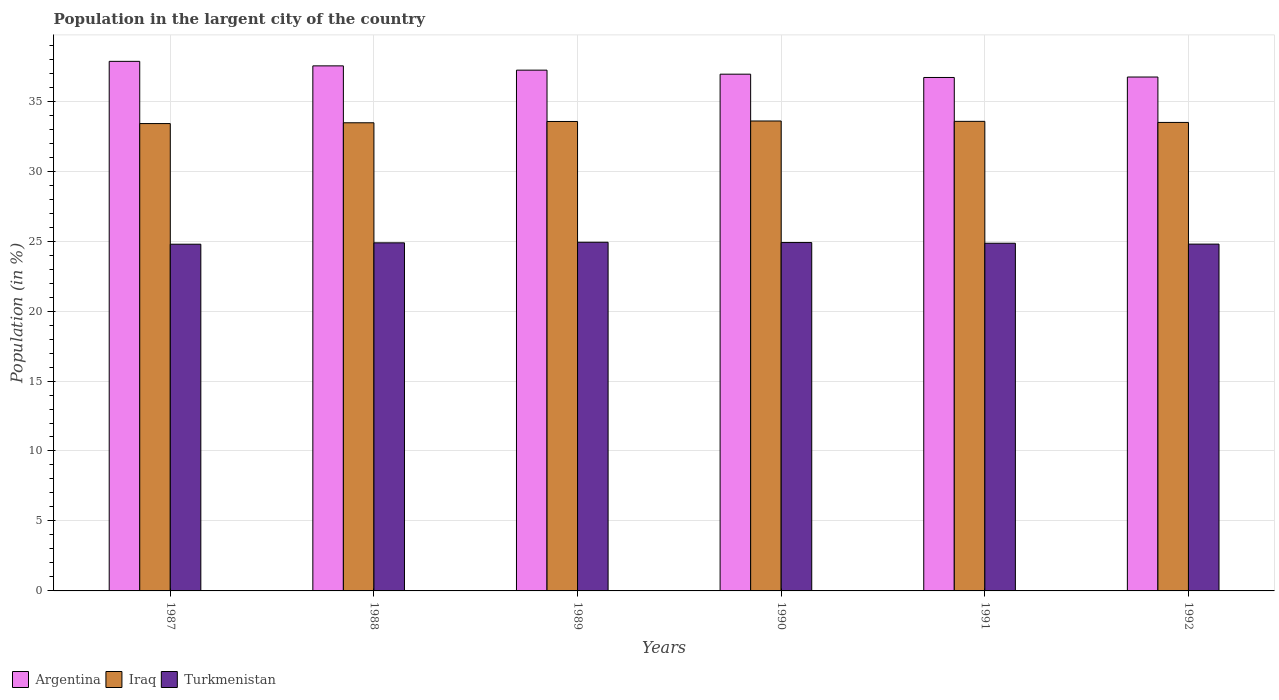Are the number of bars on each tick of the X-axis equal?
Ensure brevity in your answer.  Yes. How many bars are there on the 6th tick from the left?
Your answer should be very brief. 3. How many bars are there on the 2nd tick from the right?
Make the answer very short. 3. What is the label of the 6th group of bars from the left?
Keep it short and to the point. 1992. In how many cases, is the number of bars for a given year not equal to the number of legend labels?
Provide a short and direct response. 0. What is the percentage of population in the largent city in Turkmenistan in 1987?
Offer a terse response. 24.78. Across all years, what is the maximum percentage of population in the largent city in Turkmenistan?
Your response must be concise. 24.92. Across all years, what is the minimum percentage of population in the largent city in Turkmenistan?
Offer a terse response. 24.78. What is the total percentage of population in the largent city in Turkmenistan in the graph?
Ensure brevity in your answer.  149.1. What is the difference between the percentage of population in the largent city in Argentina in 1987 and that in 1991?
Ensure brevity in your answer.  1.15. What is the difference between the percentage of population in the largent city in Iraq in 1987 and the percentage of population in the largent city in Turkmenistan in 1991?
Provide a short and direct response. 8.55. What is the average percentage of population in the largent city in Turkmenistan per year?
Give a very brief answer. 24.85. In the year 1991, what is the difference between the percentage of population in the largent city in Argentina and percentage of population in the largent city in Turkmenistan?
Keep it short and to the point. 11.85. In how many years, is the percentage of population in the largent city in Argentina greater than 3 %?
Provide a succinct answer. 6. What is the ratio of the percentage of population in the largent city in Turkmenistan in 1991 to that in 1992?
Give a very brief answer. 1. Is the percentage of population in the largent city in Iraq in 1987 less than that in 1990?
Keep it short and to the point. Yes. What is the difference between the highest and the second highest percentage of population in the largent city in Argentina?
Your response must be concise. 0.32. What is the difference between the highest and the lowest percentage of population in the largent city in Argentina?
Your response must be concise. 1.15. What does the 1st bar from the left in 1990 represents?
Give a very brief answer. Argentina. What does the 2nd bar from the right in 1989 represents?
Offer a terse response. Iraq. How many bars are there?
Keep it short and to the point. 18. Are all the bars in the graph horizontal?
Keep it short and to the point. No. Does the graph contain grids?
Your answer should be compact. Yes. What is the title of the graph?
Make the answer very short. Population in the largent city of the country. What is the label or title of the X-axis?
Make the answer very short. Years. What is the label or title of the Y-axis?
Offer a very short reply. Population (in %). What is the Population (in %) in Argentina in 1987?
Your response must be concise. 37.85. What is the Population (in %) of Iraq in 1987?
Keep it short and to the point. 33.4. What is the Population (in %) of Turkmenistan in 1987?
Your response must be concise. 24.78. What is the Population (in %) of Argentina in 1988?
Ensure brevity in your answer.  37.52. What is the Population (in %) in Iraq in 1988?
Your answer should be very brief. 33.46. What is the Population (in %) of Turkmenistan in 1988?
Offer a very short reply. 24.88. What is the Population (in %) of Argentina in 1989?
Give a very brief answer. 37.22. What is the Population (in %) in Iraq in 1989?
Make the answer very short. 33.55. What is the Population (in %) of Turkmenistan in 1989?
Give a very brief answer. 24.92. What is the Population (in %) in Argentina in 1990?
Offer a very short reply. 36.93. What is the Population (in %) of Iraq in 1990?
Keep it short and to the point. 33.58. What is the Population (in %) in Turkmenistan in 1990?
Offer a terse response. 24.9. What is the Population (in %) of Argentina in 1991?
Offer a terse response. 36.69. What is the Population (in %) of Iraq in 1991?
Provide a succinct answer. 33.56. What is the Population (in %) of Turkmenistan in 1991?
Your answer should be compact. 24.85. What is the Population (in %) of Argentina in 1992?
Ensure brevity in your answer.  36.73. What is the Population (in %) of Iraq in 1992?
Your answer should be compact. 33.48. What is the Population (in %) in Turkmenistan in 1992?
Provide a succinct answer. 24.78. Across all years, what is the maximum Population (in %) in Argentina?
Make the answer very short. 37.85. Across all years, what is the maximum Population (in %) in Iraq?
Your response must be concise. 33.58. Across all years, what is the maximum Population (in %) of Turkmenistan?
Offer a very short reply. 24.92. Across all years, what is the minimum Population (in %) of Argentina?
Make the answer very short. 36.69. Across all years, what is the minimum Population (in %) in Iraq?
Provide a short and direct response. 33.4. Across all years, what is the minimum Population (in %) of Turkmenistan?
Your answer should be very brief. 24.78. What is the total Population (in %) of Argentina in the graph?
Keep it short and to the point. 222.93. What is the total Population (in %) in Iraq in the graph?
Make the answer very short. 201.02. What is the total Population (in %) in Turkmenistan in the graph?
Your answer should be compact. 149.1. What is the difference between the Population (in %) of Argentina in 1987 and that in 1988?
Keep it short and to the point. 0.32. What is the difference between the Population (in %) of Iraq in 1987 and that in 1988?
Provide a succinct answer. -0.06. What is the difference between the Population (in %) in Turkmenistan in 1987 and that in 1988?
Offer a very short reply. -0.1. What is the difference between the Population (in %) of Argentina in 1987 and that in 1989?
Offer a very short reply. 0.63. What is the difference between the Population (in %) of Iraq in 1987 and that in 1989?
Your answer should be compact. -0.15. What is the difference between the Population (in %) of Turkmenistan in 1987 and that in 1989?
Your answer should be compact. -0.14. What is the difference between the Population (in %) of Argentina in 1987 and that in 1990?
Provide a succinct answer. 0.92. What is the difference between the Population (in %) of Iraq in 1987 and that in 1990?
Keep it short and to the point. -0.18. What is the difference between the Population (in %) in Turkmenistan in 1987 and that in 1990?
Make the answer very short. -0.12. What is the difference between the Population (in %) in Argentina in 1987 and that in 1991?
Your response must be concise. 1.15. What is the difference between the Population (in %) of Iraq in 1987 and that in 1991?
Make the answer very short. -0.16. What is the difference between the Population (in %) of Turkmenistan in 1987 and that in 1991?
Make the answer very short. -0.07. What is the difference between the Population (in %) in Argentina in 1987 and that in 1992?
Offer a very short reply. 1.12. What is the difference between the Population (in %) of Iraq in 1987 and that in 1992?
Your answer should be very brief. -0.08. What is the difference between the Population (in %) of Turkmenistan in 1987 and that in 1992?
Give a very brief answer. -0.01. What is the difference between the Population (in %) in Argentina in 1988 and that in 1989?
Offer a terse response. 0.31. What is the difference between the Population (in %) in Iraq in 1988 and that in 1989?
Your response must be concise. -0.09. What is the difference between the Population (in %) in Turkmenistan in 1988 and that in 1989?
Your answer should be very brief. -0.04. What is the difference between the Population (in %) in Argentina in 1988 and that in 1990?
Offer a terse response. 0.59. What is the difference between the Population (in %) of Iraq in 1988 and that in 1990?
Provide a succinct answer. -0.13. What is the difference between the Population (in %) in Turkmenistan in 1988 and that in 1990?
Your answer should be compact. -0.02. What is the difference between the Population (in %) of Argentina in 1988 and that in 1991?
Ensure brevity in your answer.  0.83. What is the difference between the Population (in %) of Iraq in 1988 and that in 1991?
Provide a short and direct response. -0.1. What is the difference between the Population (in %) of Turkmenistan in 1988 and that in 1991?
Ensure brevity in your answer.  0.03. What is the difference between the Population (in %) of Argentina in 1988 and that in 1992?
Keep it short and to the point. 0.8. What is the difference between the Population (in %) of Iraq in 1988 and that in 1992?
Provide a succinct answer. -0.03. What is the difference between the Population (in %) in Turkmenistan in 1988 and that in 1992?
Your answer should be compact. 0.09. What is the difference between the Population (in %) of Argentina in 1989 and that in 1990?
Your response must be concise. 0.29. What is the difference between the Population (in %) of Iraq in 1989 and that in 1990?
Ensure brevity in your answer.  -0.04. What is the difference between the Population (in %) in Turkmenistan in 1989 and that in 1990?
Offer a very short reply. 0.02. What is the difference between the Population (in %) in Argentina in 1989 and that in 1991?
Offer a very short reply. 0.52. What is the difference between the Population (in %) in Iraq in 1989 and that in 1991?
Your response must be concise. -0.01. What is the difference between the Population (in %) of Turkmenistan in 1989 and that in 1991?
Provide a short and direct response. 0.07. What is the difference between the Population (in %) of Argentina in 1989 and that in 1992?
Offer a very short reply. 0.49. What is the difference between the Population (in %) in Iraq in 1989 and that in 1992?
Give a very brief answer. 0.07. What is the difference between the Population (in %) in Turkmenistan in 1989 and that in 1992?
Make the answer very short. 0.13. What is the difference between the Population (in %) of Argentina in 1990 and that in 1991?
Your response must be concise. 0.24. What is the difference between the Population (in %) of Iraq in 1990 and that in 1991?
Offer a terse response. 0.03. What is the difference between the Population (in %) in Turkmenistan in 1990 and that in 1991?
Your answer should be compact. 0.05. What is the difference between the Population (in %) in Argentina in 1990 and that in 1992?
Give a very brief answer. 0.2. What is the difference between the Population (in %) of Iraq in 1990 and that in 1992?
Offer a very short reply. 0.1. What is the difference between the Population (in %) of Turkmenistan in 1990 and that in 1992?
Provide a short and direct response. 0.11. What is the difference between the Population (in %) in Argentina in 1991 and that in 1992?
Make the answer very short. -0.03. What is the difference between the Population (in %) in Iraq in 1991 and that in 1992?
Make the answer very short. 0.08. What is the difference between the Population (in %) of Turkmenistan in 1991 and that in 1992?
Ensure brevity in your answer.  0.06. What is the difference between the Population (in %) of Argentina in 1987 and the Population (in %) of Iraq in 1988?
Your answer should be compact. 4.39. What is the difference between the Population (in %) of Argentina in 1987 and the Population (in %) of Turkmenistan in 1988?
Give a very brief answer. 12.97. What is the difference between the Population (in %) in Iraq in 1987 and the Population (in %) in Turkmenistan in 1988?
Your answer should be compact. 8.52. What is the difference between the Population (in %) of Argentina in 1987 and the Population (in %) of Iraq in 1989?
Give a very brief answer. 4.3. What is the difference between the Population (in %) of Argentina in 1987 and the Population (in %) of Turkmenistan in 1989?
Offer a terse response. 12.93. What is the difference between the Population (in %) of Iraq in 1987 and the Population (in %) of Turkmenistan in 1989?
Your response must be concise. 8.48. What is the difference between the Population (in %) of Argentina in 1987 and the Population (in %) of Iraq in 1990?
Provide a succinct answer. 4.26. What is the difference between the Population (in %) of Argentina in 1987 and the Population (in %) of Turkmenistan in 1990?
Give a very brief answer. 12.95. What is the difference between the Population (in %) in Iraq in 1987 and the Population (in %) in Turkmenistan in 1990?
Your answer should be very brief. 8.5. What is the difference between the Population (in %) of Argentina in 1987 and the Population (in %) of Iraq in 1991?
Provide a succinct answer. 4.29. What is the difference between the Population (in %) in Argentina in 1987 and the Population (in %) in Turkmenistan in 1991?
Your response must be concise. 13. What is the difference between the Population (in %) of Iraq in 1987 and the Population (in %) of Turkmenistan in 1991?
Make the answer very short. 8.55. What is the difference between the Population (in %) of Argentina in 1987 and the Population (in %) of Iraq in 1992?
Give a very brief answer. 4.36. What is the difference between the Population (in %) of Argentina in 1987 and the Population (in %) of Turkmenistan in 1992?
Your response must be concise. 13.06. What is the difference between the Population (in %) of Iraq in 1987 and the Population (in %) of Turkmenistan in 1992?
Your answer should be compact. 8.61. What is the difference between the Population (in %) of Argentina in 1988 and the Population (in %) of Iraq in 1989?
Ensure brevity in your answer.  3.97. What is the difference between the Population (in %) in Argentina in 1988 and the Population (in %) in Turkmenistan in 1989?
Provide a short and direct response. 12.61. What is the difference between the Population (in %) of Iraq in 1988 and the Population (in %) of Turkmenistan in 1989?
Your response must be concise. 8.54. What is the difference between the Population (in %) in Argentina in 1988 and the Population (in %) in Iraq in 1990?
Offer a terse response. 3.94. What is the difference between the Population (in %) in Argentina in 1988 and the Population (in %) in Turkmenistan in 1990?
Offer a terse response. 12.63. What is the difference between the Population (in %) of Iraq in 1988 and the Population (in %) of Turkmenistan in 1990?
Offer a terse response. 8.56. What is the difference between the Population (in %) of Argentina in 1988 and the Population (in %) of Iraq in 1991?
Offer a terse response. 3.97. What is the difference between the Population (in %) of Argentina in 1988 and the Population (in %) of Turkmenistan in 1991?
Offer a terse response. 12.68. What is the difference between the Population (in %) of Iraq in 1988 and the Population (in %) of Turkmenistan in 1991?
Provide a short and direct response. 8.61. What is the difference between the Population (in %) in Argentina in 1988 and the Population (in %) in Iraq in 1992?
Offer a very short reply. 4.04. What is the difference between the Population (in %) in Argentina in 1988 and the Population (in %) in Turkmenistan in 1992?
Give a very brief answer. 12.74. What is the difference between the Population (in %) of Iraq in 1988 and the Population (in %) of Turkmenistan in 1992?
Your answer should be compact. 8.67. What is the difference between the Population (in %) of Argentina in 1989 and the Population (in %) of Iraq in 1990?
Offer a terse response. 3.63. What is the difference between the Population (in %) in Argentina in 1989 and the Population (in %) in Turkmenistan in 1990?
Provide a succinct answer. 12.32. What is the difference between the Population (in %) of Iraq in 1989 and the Population (in %) of Turkmenistan in 1990?
Offer a very short reply. 8.65. What is the difference between the Population (in %) of Argentina in 1989 and the Population (in %) of Iraq in 1991?
Make the answer very short. 3.66. What is the difference between the Population (in %) in Argentina in 1989 and the Population (in %) in Turkmenistan in 1991?
Provide a succinct answer. 12.37. What is the difference between the Population (in %) of Iraq in 1989 and the Population (in %) of Turkmenistan in 1991?
Provide a short and direct response. 8.7. What is the difference between the Population (in %) in Argentina in 1989 and the Population (in %) in Iraq in 1992?
Offer a very short reply. 3.74. What is the difference between the Population (in %) of Argentina in 1989 and the Population (in %) of Turkmenistan in 1992?
Provide a succinct answer. 12.43. What is the difference between the Population (in %) of Iraq in 1989 and the Population (in %) of Turkmenistan in 1992?
Your answer should be compact. 8.76. What is the difference between the Population (in %) in Argentina in 1990 and the Population (in %) in Iraq in 1991?
Your answer should be very brief. 3.37. What is the difference between the Population (in %) in Argentina in 1990 and the Population (in %) in Turkmenistan in 1991?
Offer a terse response. 12.08. What is the difference between the Population (in %) of Iraq in 1990 and the Population (in %) of Turkmenistan in 1991?
Your answer should be compact. 8.74. What is the difference between the Population (in %) of Argentina in 1990 and the Population (in %) of Iraq in 1992?
Make the answer very short. 3.45. What is the difference between the Population (in %) in Argentina in 1990 and the Population (in %) in Turkmenistan in 1992?
Offer a very short reply. 12.14. What is the difference between the Population (in %) of Iraq in 1990 and the Population (in %) of Turkmenistan in 1992?
Provide a succinct answer. 8.8. What is the difference between the Population (in %) in Argentina in 1991 and the Population (in %) in Iraq in 1992?
Provide a short and direct response. 3.21. What is the difference between the Population (in %) of Argentina in 1991 and the Population (in %) of Turkmenistan in 1992?
Provide a succinct answer. 11.91. What is the difference between the Population (in %) in Iraq in 1991 and the Population (in %) in Turkmenistan in 1992?
Your answer should be very brief. 8.77. What is the average Population (in %) in Argentina per year?
Your answer should be very brief. 37.16. What is the average Population (in %) in Iraq per year?
Your answer should be compact. 33.5. What is the average Population (in %) in Turkmenistan per year?
Your response must be concise. 24.85. In the year 1987, what is the difference between the Population (in %) in Argentina and Population (in %) in Iraq?
Offer a very short reply. 4.45. In the year 1987, what is the difference between the Population (in %) in Argentina and Population (in %) in Turkmenistan?
Provide a succinct answer. 13.07. In the year 1987, what is the difference between the Population (in %) of Iraq and Population (in %) of Turkmenistan?
Offer a terse response. 8.62. In the year 1988, what is the difference between the Population (in %) of Argentina and Population (in %) of Iraq?
Your answer should be compact. 4.07. In the year 1988, what is the difference between the Population (in %) in Argentina and Population (in %) in Turkmenistan?
Give a very brief answer. 12.65. In the year 1988, what is the difference between the Population (in %) of Iraq and Population (in %) of Turkmenistan?
Give a very brief answer. 8.58. In the year 1989, what is the difference between the Population (in %) of Argentina and Population (in %) of Iraq?
Your answer should be compact. 3.67. In the year 1989, what is the difference between the Population (in %) in Argentina and Population (in %) in Turkmenistan?
Offer a terse response. 12.3. In the year 1989, what is the difference between the Population (in %) in Iraq and Population (in %) in Turkmenistan?
Offer a terse response. 8.63. In the year 1990, what is the difference between the Population (in %) in Argentina and Population (in %) in Iraq?
Give a very brief answer. 3.34. In the year 1990, what is the difference between the Population (in %) of Argentina and Population (in %) of Turkmenistan?
Your response must be concise. 12.03. In the year 1990, what is the difference between the Population (in %) of Iraq and Population (in %) of Turkmenistan?
Your answer should be very brief. 8.69. In the year 1991, what is the difference between the Population (in %) in Argentina and Population (in %) in Iraq?
Ensure brevity in your answer.  3.14. In the year 1991, what is the difference between the Population (in %) of Argentina and Population (in %) of Turkmenistan?
Give a very brief answer. 11.85. In the year 1991, what is the difference between the Population (in %) of Iraq and Population (in %) of Turkmenistan?
Keep it short and to the point. 8.71. In the year 1992, what is the difference between the Population (in %) in Argentina and Population (in %) in Iraq?
Provide a short and direct response. 3.24. In the year 1992, what is the difference between the Population (in %) in Argentina and Population (in %) in Turkmenistan?
Offer a terse response. 11.94. In the year 1992, what is the difference between the Population (in %) in Iraq and Population (in %) in Turkmenistan?
Your answer should be very brief. 8.7. What is the ratio of the Population (in %) of Argentina in 1987 to that in 1988?
Provide a short and direct response. 1.01. What is the ratio of the Population (in %) in Iraq in 1987 to that in 1988?
Your answer should be compact. 1. What is the ratio of the Population (in %) of Argentina in 1987 to that in 1989?
Your answer should be very brief. 1.02. What is the ratio of the Population (in %) of Iraq in 1987 to that in 1989?
Offer a very short reply. 1. What is the ratio of the Population (in %) of Turkmenistan in 1987 to that in 1989?
Offer a very short reply. 0.99. What is the ratio of the Population (in %) in Argentina in 1987 to that in 1990?
Ensure brevity in your answer.  1.02. What is the ratio of the Population (in %) in Turkmenistan in 1987 to that in 1990?
Give a very brief answer. 1. What is the ratio of the Population (in %) of Argentina in 1987 to that in 1991?
Your answer should be compact. 1.03. What is the ratio of the Population (in %) of Argentina in 1987 to that in 1992?
Keep it short and to the point. 1.03. What is the ratio of the Population (in %) in Turkmenistan in 1987 to that in 1992?
Make the answer very short. 1. What is the ratio of the Population (in %) of Argentina in 1988 to that in 1989?
Provide a succinct answer. 1.01. What is the ratio of the Population (in %) in Turkmenistan in 1988 to that in 1989?
Ensure brevity in your answer.  1. What is the ratio of the Population (in %) in Argentina in 1988 to that in 1990?
Offer a very short reply. 1.02. What is the ratio of the Population (in %) in Iraq in 1988 to that in 1990?
Keep it short and to the point. 1. What is the ratio of the Population (in %) of Argentina in 1988 to that in 1991?
Give a very brief answer. 1.02. What is the ratio of the Population (in %) of Argentina in 1988 to that in 1992?
Make the answer very short. 1.02. What is the ratio of the Population (in %) of Iraq in 1988 to that in 1992?
Your response must be concise. 1. What is the ratio of the Population (in %) of Turkmenistan in 1988 to that in 1992?
Keep it short and to the point. 1. What is the ratio of the Population (in %) of Argentina in 1989 to that in 1990?
Ensure brevity in your answer.  1.01. What is the ratio of the Population (in %) in Iraq in 1989 to that in 1990?
Ensure brevity in your answer.  1. What is the ratio of the Population (in %) in Argentina in 1989 to that in 1991?
Give a very brief answer. 1.01. What is the ratio of the Population (in %) in Iraq in 1989 to that in 1991?
Give a very brief answer. 1. What is the ratio of the Population (in %) of Argentina in 1989 to that in 1992?
Your answer should be compact. 1.01. What is the ratio of the Population (in %) in Turkmenistan in 1989 to that in 1992?
Your response must be concise. 1.01. What is the ratio of the Population (in %) of Argentina in 1990 to that in 1991?
Offer a very short reply. 1.01. What is the ratio of the Population (in %) of Argentina in 1990 to that in 1992?
Provide a succinct answer. 1.01. What is the ratio of the Population (in %) of Turkmenistan in 1990 to that in 1992?
Your response must be concise. 1. What is the ratio of the Population (in %) of Argentina in 1991 to that in 1992?
Your response must be concise. 1. What is the ratio of the Population (in %) of Iraq in 1991 to that in 1992?
Your answer should be compact. 1. What is the ratio of the Population (in %) in Turkmenistan in 1991 to that in 1992?
Provide a short and direct response. 1. What is the difference between the highest and the second highest Population (in %) of Argentina?
Give a very brief answer. 0.32. What is the difference between the highest and the second highest Population (in %) of Iraq?
Give a very brief answer. 0.03. What is the difference between the highest and the second highest Population (in %) in Turkmenistan?
Offer a very short reply. 0.02. What is the difference between the highest and the lowest Population (in %) in Argentina?
Provide a succinct answer. 1.15. What is the difference between the highest and the lowest Population (in %) of Iraq?
Give a very brief answer. 0.18. What is the difference between the highest and the lowest Population (in %) in Turkmenistan?
Ensure brevity in your answer.  0.14. 